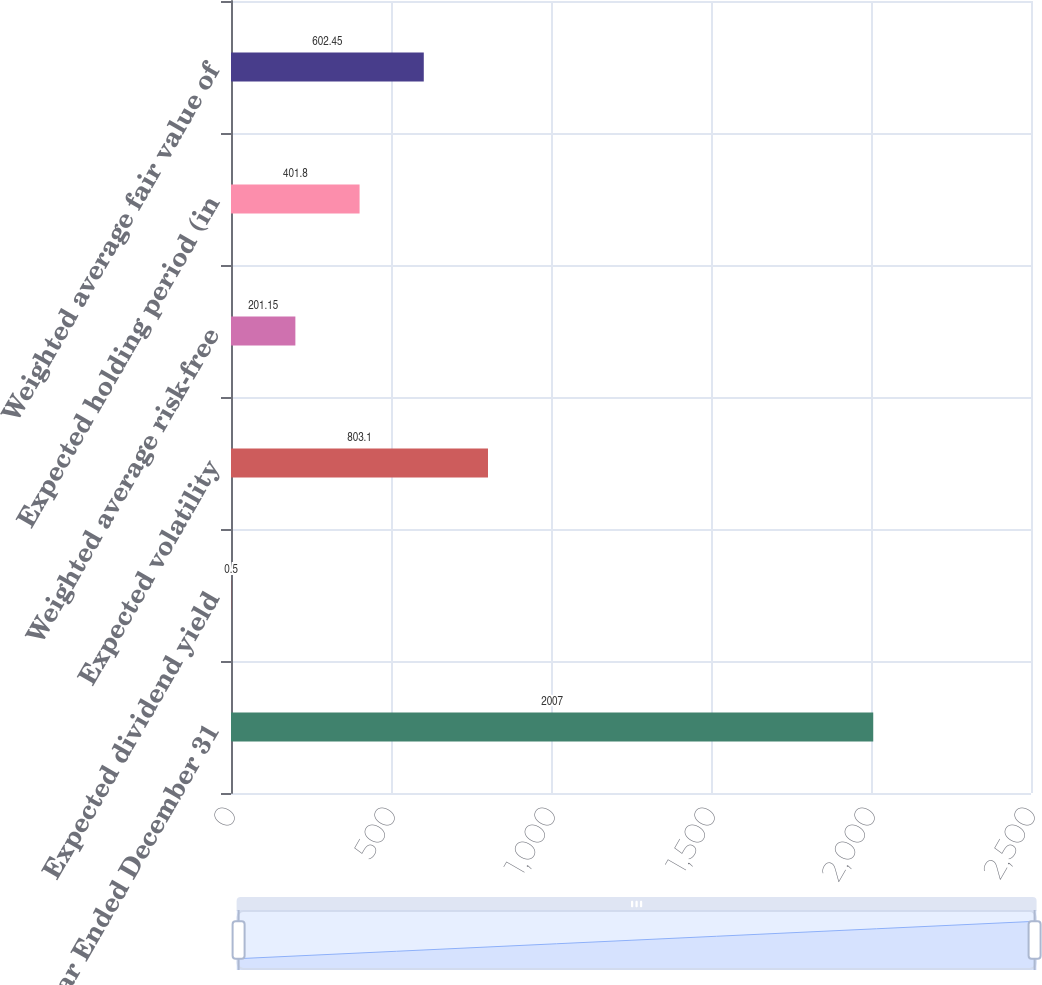Convert chart. <chart><loc_0><loc_0><loc_500><loc_500><bar_chart><fcel>Year Ended December 31<fcel>Expected dividend yield<fcel>Expected volatility<fcel>Weighted average risk-free<fcel>Expected holding period (in<fcel>Weighted average fair value of<nl><fcel>2007<fcel>0.5<fcel>803.1<fcel>201.15<fcel>401.8<fcel>602.45<nl></chart> 